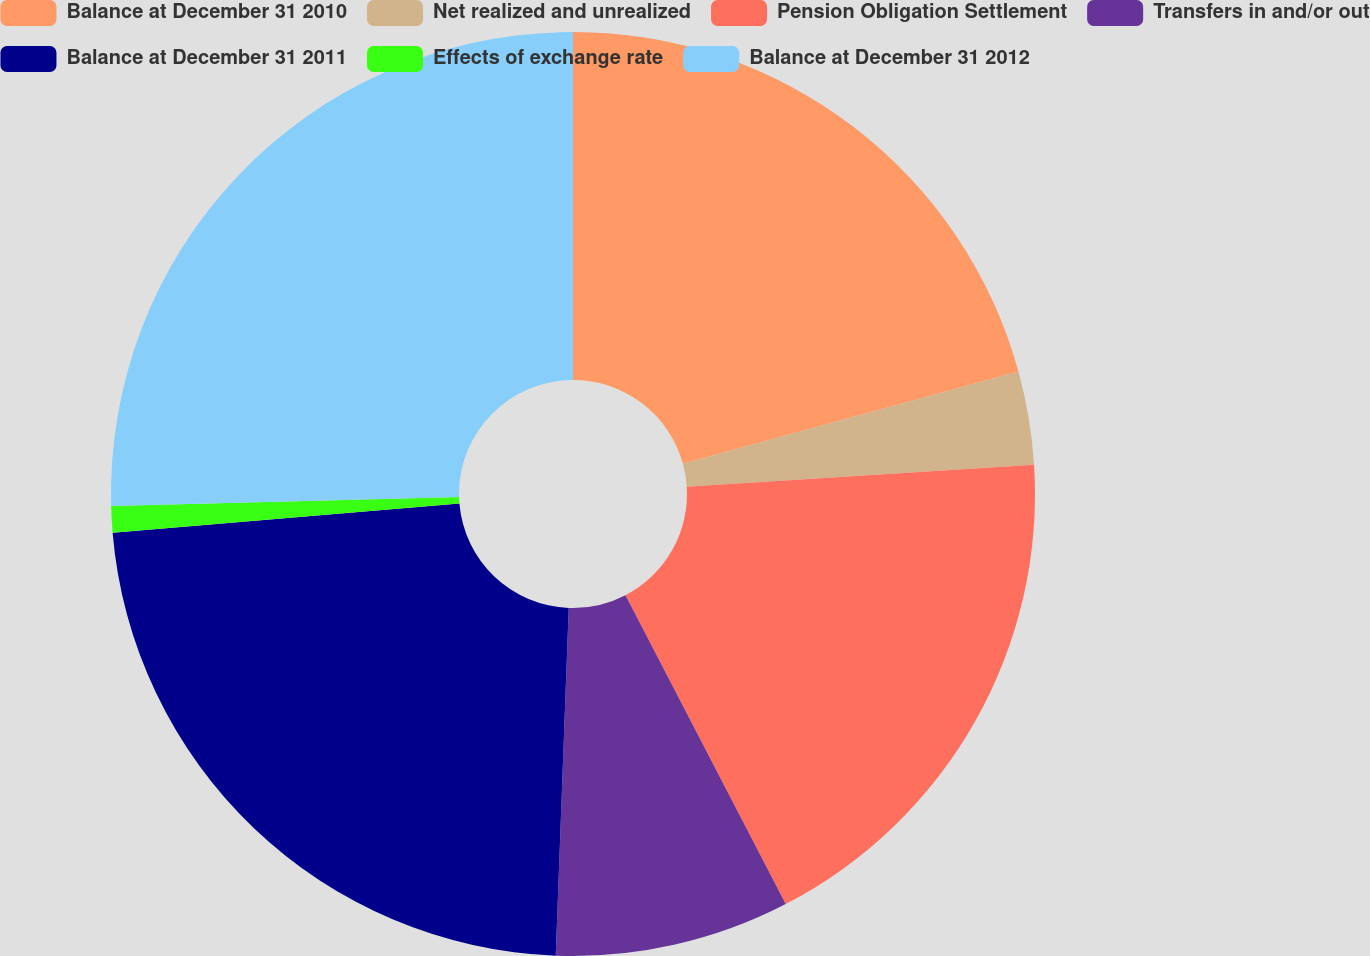Convert chart. <chart><loc_0><loc_0><loc_500><loc_500><pie_chart><fcel>Balance at December 31 2010<fcel>Net realized and unrealized<fcel>Pension Obligation Settlement<fcel>Transfers in and/or out<fcel>Balance at December 31 2011<fcel>Effects of exchange rate<fcel>Balance at December 31 2012<nl><fcel>20.73%<fcel>3.26%<fcel>18.39%<fcel>8.21%<fcel>23.07%<fcel>0.92%<fcel>25.41%<nl></chart> 